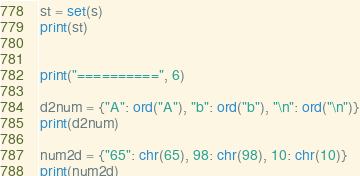Convert code to text. <code><loc_0><loc_0><loc_500><loc_500><_Python_>st = set(s)
print(st)


print("==========", 6)

d2num = {"A": ord("A"), "b": ord("b"), "\n": ord("\n")}
print(d2num)

num2d = {"65": chr(65), 98: chr(98), 10: chr(10)}
print(num2d)
</code> 